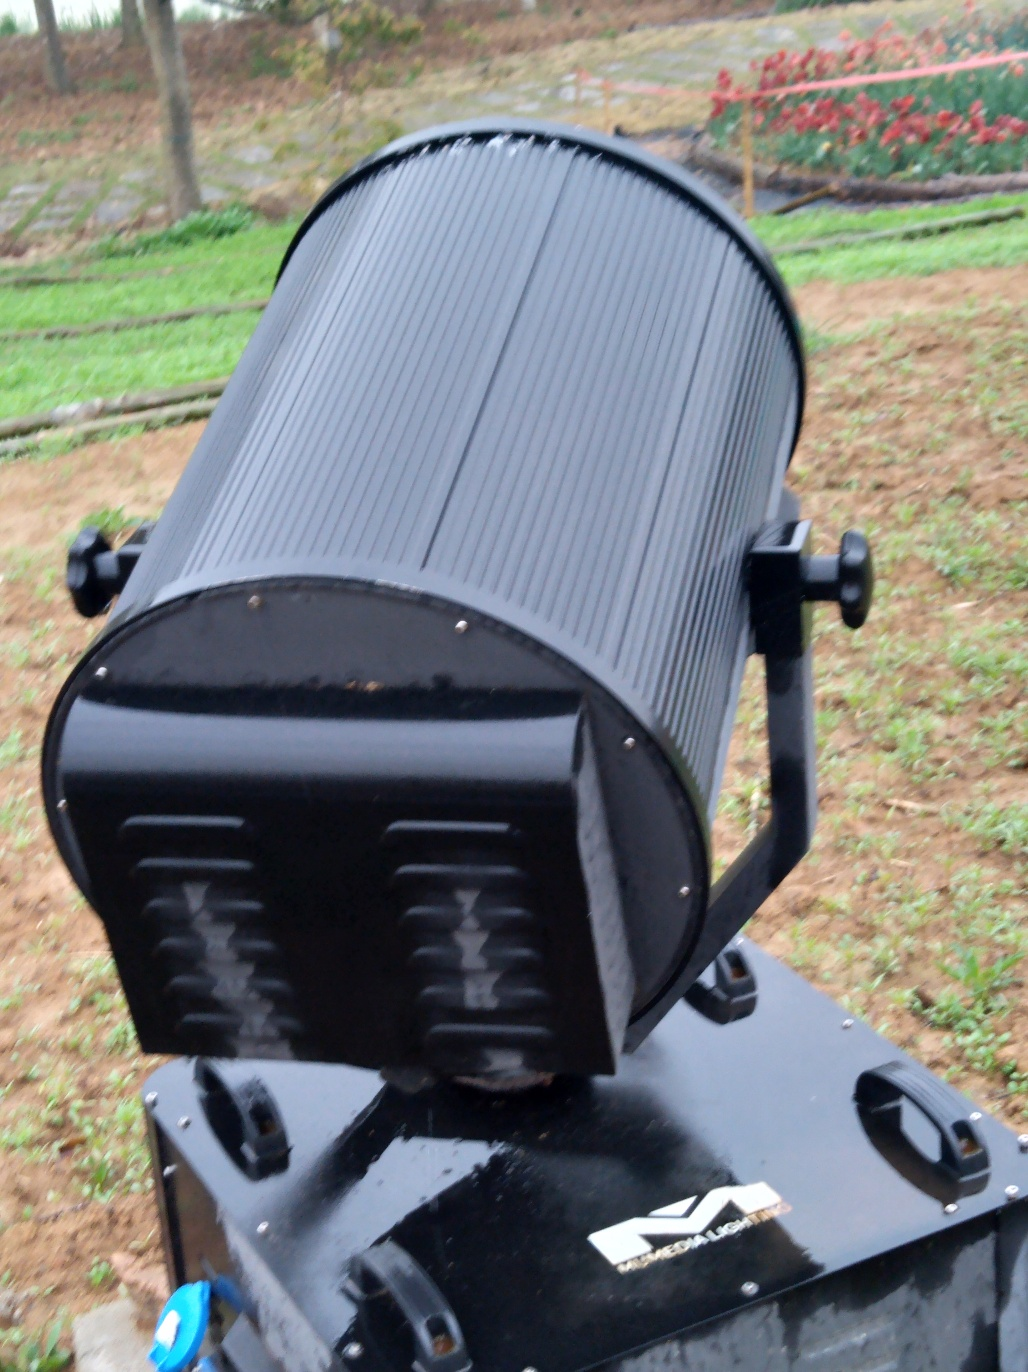How does the object function and in what environment is it typically used? The object appears to be an industrial or heavy-duty piece of equipment, possibly part of machinery or an engine. It features a sturdy metal construction and is probably designed to operate outdoors given the durable materials and visible wear that suggest exposure to the elements. Can you determine its state or condition? While there are signs of usage, such as scuff marks and minor surface weathering, the object's integral structure remains intact. This suggests that it is in a functional state, ready for operation or currently in service. 